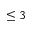Convert formula to latex. <formula><loc_0><loc_0><loc_500><loc_500>\leq 3</formula> 